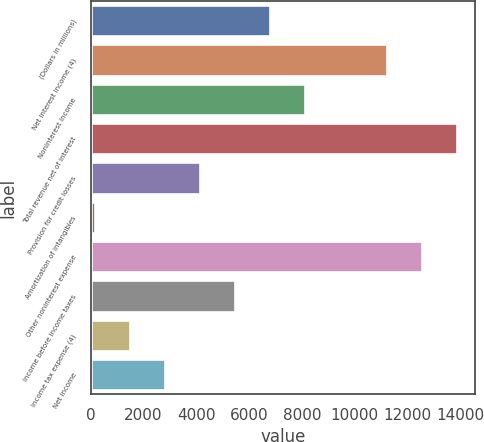Convert chart. <chart><loc_0><loc_0><loc_500><loc_500><bar_chart><fcel>(Dollars in millions)<fcel>Net interest income (4)<fcel>Noninterest income<fcel>Total revenue net of interest<fcel>Provision for credit losses<fcel>Amortization of intangibles<fcel>Other noninterest expense<fcel>Income before income taxes<fcel>Income tax expense (4)<fcel>Net income<nl><fcel>6797.5<fcel>11217<fcel>8121.4<fcel>13864.8<fcel>4149.7<fcel>178<fcel>12540.9<fcel>5473.6<fcel>1501.9<fcel>2825.8<nl></chart> 